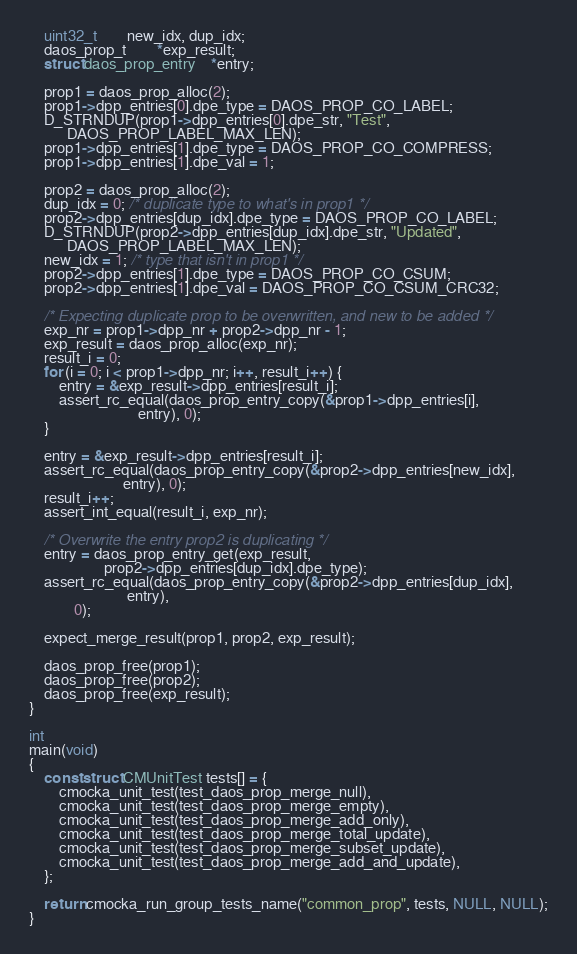<code> <loc_0><loc_0><loc_500><loc_500><_C_>	uint32_t		new_idx, dup_idx;
	daos_prop_t		*exp_result;
	struct daos_prop_entry	*entry;

	prop1 = daos_prop_alloc(2);
	prop1->dpp_entries[0].dpe_type = DAOS_PROP_CO_LABEL;
	D_STRNDUP(prop1->dpp_entries[0].dpe_str, "Test",
		  DAOS_PROP_LABEL_MAX_LEN);
	prop1->dpp_entries[1].dpe_type = DAOS_PROP_CO_COMPRESS;
	prop1->dpp_entries[1].dpe_val = 1;

	prop2 = daos_prop_alloc(2);
	dup_idx = 0; /* duplicate type to what's in prop1 */
	prop2->dpp_entries[dup_idx].dpe_type = DAOS_PROP_CO_LABEL;
	D_STRNDUP(prop2->dpp_entries[dup_idx].dpe_str, "Updated",
		  DAOS_PROP_LABEL_MAX_LEN);
	new_idx = 1; /* type that isn't in prop1 */
	prop2->dpp_entries[1].dpe_type = DAOS_PROP_CO_CSUM;
	prop2->dpp_entries[1].dpe_val = DAOS_PROP_CO_CSUM_CRC32;

	/* Expecting duplicate prop to be overwritten, and new to be added */
	exp_nr = prop1->dpp_nr + prop2->dpp_nr - 1;
	exp_result = daos_prop_alloc(exp_nr);
	result_i = 0;
	for (i = 0; i < prop1->dpp_nr; i++, result_i++) {
		entry = &exp_result->dpp_entries[result_i];
		assert_rc_equal(daos_prop_entry_copy(&prop1->dpp_entries[i],
						     entry), 0);
	}

	entry = &exp_result->dpp_entries[result_i];
	assert_rc_equal(daos_prop_entry_copy(&prop2->dpp_entries[new_idx],
					     entry), 0);
	result_i++;
	assert_int_equal(result_i, exp_nr);

	/* Overwrite the entry prop2 is duplicating */
	entry = daos_prop_entry_get(exp_result,
				    prop2->dpp_entries[dup_idx].dpe_type);
	assert_rc_equal(daos_prop_entry_copy(&prop2->dpp_entries[dup_idx],
					      entry),
			0);

	expect_merge_result(prop1, prop2, exp_result);

	daos_prop_free(prop1);
	daos_prop_free(prop2);
	daos_prop_free(exp_result);
}

int
main(void)
{
	const struct CMUnitTest tests[] = {
		cmocka_unit_test(test_daos_prop_merge_null),
		cmocka_unit_test(test_daos_prop_merge_empty),
		cmocka_unit_test(test_daos_prop_merge_add_only),
		cmocka_unit_test(test_daos_prop_merge_total_update),
		cmocka_unit_test(test_daos_prop_merge_subset_update),
		cmocka_unit_test(test_daos_prop_merge_add_and_update),
	};

	return cmocka_run_group_tests_name("common_prop", tests, NULL, NULL);
}
</code> 